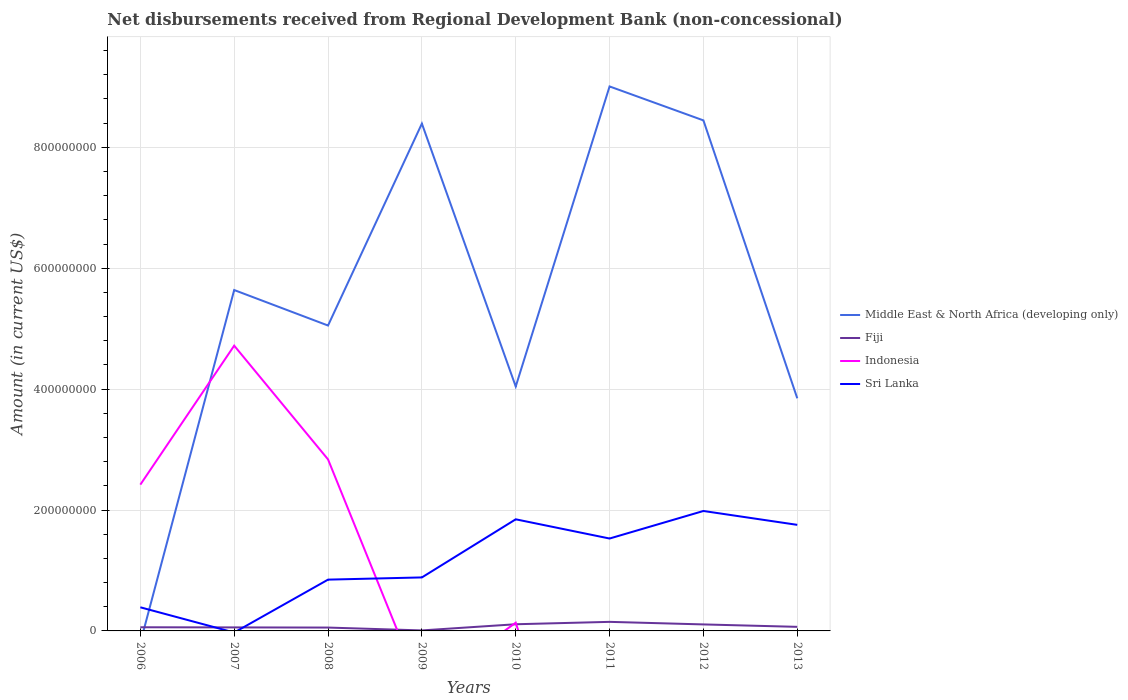Does the line corresponding to Fiji intersect with the line corresponding to Indonesia?
Your response must be concise. Yes. Across all years, what is the maximum amount of disbursements received from Regional Development Bank in Fiji?
Your response must be concise. 8.38e+05. What is the total amount of disbursements received from Regional Development Bank in Middle East & North Africa (developing only) in the graph?
Give a very brief answer. -2.75e+08. What is the difference between the highest and the second highest amount of disbursements received from Regional Development Bank in Middle East & North Africa (developing only)?
Keep it short and to the point. 9.01e+08. How many lines are there?
Your response must be concise. 4. How many years are there in the graph?
Make the answer very short. 8. What is the difference between two consecutive major ticks on the Y-axis?
Provide a succinct answer. 2.00e+08. Does the graph contain grids?
Your answer should be very brief. Yes. What is the title of the graph?
Offer a very short reply. Net disbursements received from Regional Development Bank (non-concessional). Does "Egypt, Arab Rep." appear as one of the legend labels in the graph?
Your answer should be very brief. No. What is the label or title of the Y-axis?
Keep it short and to the point. Amount (in current US$). What is the Amount (in current US$) in Fiji in 2006?
Provide a short and direct response. 6.05e+06. What is the Amount (in current US$) of Indonesia in 2006?
Give a very brief answer. 2.42e+08. What is the Amount (in current US$) of Sri Lanka in 2006?
Provide a succinct answer. 3.91e+07. What is the Amount (in current US$) of Middle East & North Africa (developing only) in 2007?
Your answer should be compact. 5.64e+08. What is the Amount (in current US$) in Fiji in 2007?
Keep it short and to the point. 5.80e+06. What is the Amount (in current US$) of Indonesia in 2007?
Ensure brevity in your answer.  4.72e+08. What is the Amount (in current US$) in Middle East & North Africa (developing only) in 2008?
Your response must be concise. 5.05e+08. What is the Amount (in current US$) of Fiji in 2008?
Give a very brief answer. 5.56e+06. What is the Amount (in current US$) of Indonesia in 2008?
Offer a terse response. 2.84e+08. What is the Amount (in current US$) of Sri Lanka in 2008?
Offer a very short reply. 8.48e+07. What is the Amount (in current US$) in Middle East & North Africa (developing only) in 2009?
Your answer should be very brief. 8.39e+08. What is the Amount (in current US$) in Fiji in 2009?
Ensure brevity in your answer.  8.38e+05. What is the Amount (in current US$) of Sri Lanka in 2009?
Offer a terse response. 8.85e+07. What is the Amount (in current US$) in Middle East & North Africa (developing only) in 2010?
Your answer should be compact. 4.04e+08. What is the Amount (in current US$) in Fiji in 2010?
Keep it short and to the point. 1.10e+07. What is the Amount (in current US$) of Indonesia in 2010?
Offer a terse response. 1.36e+07. What is the Amount (in current US$) of Sri Lanka in 2010?
Offer a very short reply. 1.85e+08. What is the Amount (in current US$) in Middle East & North Africa (developing only) in 2011?
Your response must be concise. 9.01e+08. What is the Amount (in current US$) in Fiji in 2011?
Make the answer very short. 1.50e+07. What is the Amount (in current US$) of Indonesia in 2011?
Offer a very short reply. 0. What is the Amount (in current US$) in Sri Lanka in 2011?
Your answer should be compact. 1.53e+08. What is the Amount (in current US$) in Middle East & North Africa (developing only) in 2012?
Your response must be concise. 8.45e+08. What is the Amount (in current US$) in Fiji in 2012?
Give a very brief answer. 1.07e+07. What is the Amount (in current US$) in Indonesia in 2012?
Offer a very short reply. 0. What is the Amount (in current US$) in Sri Lanka in 2012?
Provide a short and direct response. 1.98e+08. What is the Amount (in current US$) of Middle East & North Africa (developing only) in 2013?
Give a very brief answer. 3.85e+08. What is the Amount (in current US$) of Fiji in 2013?
Make the answer very short. 6.74e+06. What is the Amount (in current US$) of Indonesia in 2013?
Ensure brevity in your answer.  0. What is the Amount (in current US$) of Sri Lanka in 2013?
Give a very brief answer. 1.75e+08. Across all years, what is the maximum Amount (in current US$) in Middle East & North Africa (developing only)?
Your answer should be compact. 9.01e+08. Across all years, what is the maximum Amount (in current US$) of Fiji?
Provide a succinct answer. 1.50e+07. Across all years, what is the maximum Amount (in current US$) in Indonesia?
Offer a very short reply. 4.72e+08. Across all years, what is the maximum Amount (in current US$) of Sri Lanka?
Your answer should be very brief. 1.98e+08. Across all years, what is the minimum Amount (in current US$) in Middle East & North Africa (developing only)?
Offer a very short reply. 0. Across all years, what is the minimum Amount (in current US$) of Fiji?
Offer a very short reply. 8.38e+05. Across all years, what is the minimum Amount (in current US$) in Indonesia?
Your answer should be compact. 0. What is the total Amount (in current US$) of Middle East & North Africa (developing only) in the graph?
Your answer should be compact. 4.44e+09. What is the total Amount (in current US$) of Fiji in the graph?
Your answer should be compact. 6.18e+07. What is the total Amount (in current US$) of Indonesia in the graph?
Your answer should be compact. 1.01e+09. What is the total Amount (in current US$) of Sri Lanka in the graph?
Ensure brevity in your answer.  9.24e+08. What is the difference between the Amount (in current US$) in Fiji in 2006 and that in 2007?
Your response must be concise. 2.49e+05. What is the difference between the Amount (in current US$) of Indonesia in 2006 and that in 2007?
Give a very brief answer. -2.30e+08. What is the difference between the Amount (in current US$) in Fiji in 2006 and that in 2008?
Provide a short and direct response. 4.96e+05. What is the difference between the Amount (in current US$) in Indonesia in 2006 and that in 2008?
Offer a terse response. -4.17e+07. What is the difference between the Amount (in current US$) in Sri Lanka in 2006 and that in 2008?
Offer a very short reply. -4.58e+07. What is the difference between the Amount (in current US$) of Fiji in 2006 and that in 2009?
Give a very brief answer. 5.22e+06. What is the difference between the Amount (in current US$) of Sri Lanka in 2006 and that in 2009?
Your answer should be very brief. -4.94e+07. What is the difference between the Amount (in current US$) of Fiji in 2006 and that in 2010?
Offer a terse response. -4.98e+06. What is the difference between the Amount (in current US$) in Indonesia in 2006 and that in 2010?
Give a very brief answer. 2.28e+08. What is the difference between the Amount (in current US$) in Sri Lanka in 2006 and that in 2010?
Give a very brief answer. -1.46e+08. What is the difference between the Amount (in current US$) of Fiji in 2006 and that in 2011?
Provide a short and direct response. -8.93e+06. What is the difference between the Amount (in current US$) in Sri Lanka in 2006 and that in 2011?
Give a very brief answer. -1.14e+08. What is the difference between the Amount (in current US$) of Fiji in 2006 and that in 2012?
Your response must be concise. -4.69e+06. What is the difference between the Amount (in current US$) of Sri Lanka in 2006 and that in 2012?
Your response must be concise. -1.59e+08. What is the difference between the Amount (in current US$) in Fiji in 2006 and that in 2013?
Provide a succinct answer. -6.84e+05. What is the difference between the Amount (in current US$) in Sri Lanka in 2006 and that in 2013?
Your answer should be very brief. -1.36e+08. What is the difference between the Amount (in current US$) of Middle East & North Africa (developing only) in 2007 and that in 2008?
Provide a succinct answer. 5.87e+07. What is the difference between the Amount (in current US$) of Fiji in 2007 and that in 2008?
Your response must be concise. 2.47e+05. What is the difference between the Amount (in current US$) of Indonesia in 2007 and that in 2008?
Offer a terse response. 1.88e+08. What is the difference between the Amount (in current US$) of Middle East & North Africa (developing only) in 2007 and that in 2009?
Your response must be concise. -2.75e+08. What is the difference between the Amount (in current US$) in Fiji in 2007 and that in 2009?
Offer a terse response. 4.97e+06. What is the difference between the Amount (in current US$) of Middle East & North Africa (developing only) in 2007 and that in 2010?
Your answer should be very brief. 1.60e+08. What is the difference between the Amount (in current US$) in Fiji in 2007 and that in 2010?
Your answer should be very brief. -5.23e+06. What is the difference between the Amount (in current US$) of Indonesia in 2007 and that in 2010?
Give a very brief answer. 4.58e+08. What is the difference between the Amount (in current US$) in Middle East & North Africa (developing only) in 2007 and that in 2011?
Offer a very short reply. -3.37e+08. What is the difference between the Amount (in current US$) of Fiji in 2007 and that in 2011?
Keep it short and to the point. -9.18e+06. What is the difference between the Amount (in current US$) of Middle East & North Africa (developing only) in 2007 and that in 2012?
Your answer should be very brief. -2.81e+08. What is the difference between the Amount (in current US$) in Fiji in 2007 and that in 2012?
Offer a terse response. -4.94e+06. What is the difference between the Amount (in current US$) in Middle East & North Africa (developing only) in 2007 and that in 2013?
Provide a short and direct response. 1.79e+08. What is the difference between the Amount (in current US$) of Fiji in 2007 and that in 2013?
Offer a terse response. -9.33e+05. What is the difference between the Amount (in current US$) in Middle East & North Africa (developing only) in 2008 and that in 2009?
Your response must be concise. -3.34e+08. What is the difference between the Amount (in current US$) of Fiji in 2008 and that in 2009?
Your answer should be compact. 4.72e+06. What is the difference between the Amount (in current US$) of Sri Lanka in 2008 and that in 2009?
Offer a terse response. -3.64e+06. What is the difference between the Amount (in current US$) of Middle East & North Africa (developing only) in 2008 and that in 2010?
Offer a terse response. 1.01e+08. What is the difference between the Amount (in current US$) of Fiji in 2008 and that in 2010?
Offer a very short reply. -5.48e+06. What is the difference between the Amount (in current US$) in Indonesia in 2008 and that in 2010?
Ensure brevity in your answer.  2.70e+08. What is the difference between the Amount (in current US$) in Sri Lanka in 2008 and that in 2010?
Make the answer very short. -9.98e+07. What is the difference between the Amount (in current US$) of Middle East & North Africa (developing only) in 2008 and that in 2011?
Make the answer very short. -3.96e+08. What is the difference between the Amount (in current US$) in Fiji in 2008 and that in 2011?
Keep it short and to the point. -9.43e+06. What is the difference between the Amount (in current US$) of Sri Lanka in 2008 and that in 2011?
Keep it short and to the point. -6.80e+07. What is the difference between the Amount (in current US$) in Middle East & North Africa (developing only) in 2008 and that in 2012?
Offer a very short reply. -3.39e+08. What is the difference between the Amount (in current US$) in Fiji in 2008 and that in 2012?
Offer a very short reply. -5.18e+06. What is the difference between the Amount (in current US$) in Sri Lanka in 2008 and that in 2012?
Provide a short and direct response. -1.14e+08. What is the difference between the Amount (in current US$) of Middle East & North Africa (developing only) in 2008 and that in 2013?
Keep it short and to the point. 1.20e+08. What is the difference between the Amount (in current US$) in Fiji in 2008 and that in 2013?
Offer a terse response. -1.18e+06. What is the difference between the Amount (in current US$) of Sri Lanka in 2008 and that in 2013?
Give a very brief answer. -9.06e+07. What is the difference between the Amount (in current US$) of Middle East & North Africa (developing only) in 2009 and that in 2010?
Ensure brevity in your answer.  4.35e+08. What is the difference between the Amount (in current US$) of Fiji in 2009 and that in 2010?
Your response must be concise. -1.02e+07. What is the difference between the Amount (in current US$) in Sri Lanka in 2009 and that in 2010?
Provide a short and direct response. -9.62e+07. What is the difference between the Amount (in current US$) in Middle East & North Africa (developing only) in 2009 and that in 2011?
Offer a terse response. -6.15e+07. What is the difference between the Amount (in current US$) in Fiji in 2009 and that in 2011?
Provide a short and direct response. -1.42e+07. What is the difference between the Amount (in current US$) of Sri Lanka in 2009 and that in 2011?
Provide a short and direct response. -6.44e+07. What is the difference between the Amount (in current US$) of Middle East & North Africa (developing only) in 2009 and that in 2012?
Offer a very short reply. -5.28e+06. What is the difference between the Amount (in current US$) in Fiji in 2009 and that in 2012?
Your answer should be very brief. -9.90e+06. What is the difference between the Amount (in current US$) of Sri Lanka in 2009 and that in 2012?
Provide a succinct answer. -1.10e+08. What is the difference between the Amount (in current US$) of Middle East & North Africa (developing only) in 2009 and that in 2013?
Offer a terse response. 4.54e+08. What is the difference between the Amount (in current US$) of Fiji in 2009 and that in 2013?
Offer a terse response. -5.90e+06. What is the difference between the Amount (in current US$) in Sri Lanka in 2009 and that in 2013?
Your response must be concise. -8.70e+07. What is the difference between the Amount (in current US$) of Middle East & North Africa (developing only) in 2010 and that in 2011?
Make the answer very short. -4.96e+08. What is the difference between the Amount (in current US$) of Fiji in 2010 and that in 2011?
Offer a terse response. -3.95e+06. What is the difference between the Amount (in current US$) of Sri Lanka in 2010 and that in 2011?
Ensure brevity in your answer.  3.18e+07. What is the difference between the Amount (in current US$) in Middle East & North Africa (developing only) in 2010 and that in 2012?
Offer a very short reply. -4.40e+08. What is the difference between the Amount (in current US$) in Fiji in 2010 and that in 2012?
Provide a short and direct response. 2.99e+05. What is the difference between the Amount (in current US$) of Sri Lanka in 2010 and that in 2012?
Keep it short and to the point. -1.38e+07. What is the difference between the Amount (in current US$) of Middle East & North Africa (developing only) in 2010 and that in 2013?
Give a very brief answer. 1.95e+07. What is the difference between the Amount (in current US$) of Fiji in 2010 and that in 2013?
Keep it short and to the point. 4.30e+06. What is the difference between the Amount (in current US$) in Sri Lanka in 2010 and that in 2013?
Keep it short and to the point. 9.17e+06. What is the difference between the Amount (in current US$) of Middle East & North Africa (developing only) in 2011 and that in 2012?
Make the answer very short. 5.62e+07. What is the difference between the Amount (in current US$) in Fiji in 2011 and that in 2012?
Offer a very short reply. 4.25e+06. What is the difference between the Amount (in current US$) of Sri Lanka in 2011 and that in 2012?
Make the answer very short. -4.56e+07. What is the difference between the Amount (in current US$) in Middle East & North Africa (developing only) in 2011 and that in 2013?
Provide a succinct answer. 5.16e+08. What is the difference between the Amount (in current US$) of Fiji in 2011 and that in 2013?
Make the answer very short. 8.25e+06. What is the difference between the Amount (in current US$) in Sri Lanka in 2011 and that in 2013?
Provide a succinct answer. -2.26e+07. What is the difference between the Amount (in current US$) of Middle East & North Africa (developing only) in 2012 and that in 2013?
Provide a short and direct response. 4.60e+08. What is the difference between the Amount (in current US$) in Fiji in 2012 and that in 2013?
Keep it short and to the point. 4.00e+06. What is the difference between the Amount (in current US$) in Sri Lanka in 2012 and that in 2013?
Ensure brevity in your answer.  2.29e+07. What is the difference between the Amount (in current US$) in Fiji in 2006 and the Amount (in current US$) in Indonesia in 2007?
Your answer should be compact. -4.66e+08. What is the difference between the Amount (in current US$) of Fiji in 2006 and the Amount (in current US$) of Indonesia in 2008?
Give a very brief answer. -2.78e+08. What is the difference between the Amount (in current US$) of Fiji in 2006 and the Amount (in current US$) of Sri Lanka in 2008?
Give a very brief answer. -7.88e+07. What is the difference between the Amount (in current US$) of Indonesia in 2006 and the Amount (in current US$) of Sri Lanka in 2008?
Offer a terse response. 1.57e+08. What is the difference between the Amount (in current US$) of Fiji in 2006 and the Amount (in current US$) of Sri Lanka in 2009?
Provide a succinct answer. -8.24e+07. What is the difference between the Amount (in current US$) of Indonesia in 2006 and the Amount (in current US$) of Sri Lanka in 2009?
Keep it short and to the point. 1.53e+08. What is the difference between the Amount (in current US$) in Fiji in 2006 and the Amount (in current US$) in Indonesia in 2010?
Keep it short and to the point. -7.55e+06. What is the difference between the Amount (in current US$) of Fiji in 2006 and the Amount (in current US$) of Sri Lanka in 2010?
Ensure brevity in your answer.  -1.79e+08. What is the difference between the Amount (in current US$) of Indonesia in 2006 and the Amount (in current US$) of Sri Lanka in 2010?
Keep it short and to the point. 5.73e+07. What is the difference between the Amount (in current US$) of Fiji in 2006 and the Amount (in current US$) of Sri Lanka in 2011?
Give a very brief answer. -1.47e+08. What is the difference between the Amount (in current US$) of Indonesia in 2006 and the Amount (in current US$) of Sri Lanka in 2011?
Ensure brevity in your answer.  8.91e+07. What is the difference between the Amount (in current US$) of Fiji in 2006 and the Amount (in current US$) of Sri Lanka in 2012?
Give a very brief answer. -1.92e+08. What is the difference between the Amount (in current US$) in Indonesia in 2006 and the Amount (in current US$) in Sri Lanka in 2012?
Keep it short and to the point. 4.36e+07. What is the difference between the Amount (in current US$) of Fiji in 2006 and the Amount (in current US$) of Sri Lanka in 2013?
Keep it short and to the point. -1.69e+08. What is the difference between the Amount (in current US$) of Indonesia in 2006 and the Amount (in current US$) of Sri Lanka in 2013?
Provide a succinct answer. 6.65e+07. What is the difference between the Amount (in current US$) in Middle East & North Africa (developing only) in 2007 and the Amount (in current US$) in Fiji in 2008?
Make the answer very short. 5.58e+08. What is the difference between the Amount (in current US$) of Middle East & North Africa (developing only) in 2007 and the Amount (in current US$) of Indonesia in 2008?
Ensure brevity in your answer.  2.80e+08. What is the difference between the Amount (in current US$) in Middle East & North Africa (developing only) in 2007 and the Amount (in current US$) in Sri Lanka in 2008?
Ensure brevity in your answer.  4.79e+08. What is the difference between the Amount (in current US$) in Fiji in 2007 and the Amount (in current US$) in Indonesia in 2008?
Ensure brevity in your answer.  -2.78e+08. What is the difference between the Amount (in current US$) of Fiji in 2007 and the Amount (in current US$) of Sri Lanka in 2008?
Give a very brief answer. -7.90e+07. What is the difference between the Amount (in current US$) in Indonesia in 2007 and the Amount (in current US$) in Sri Lanka in 2008?
Ensure brevity in your answer.  3.87e+08. What is the difference between the Amount (in current US$) in Middle East & North Africa (developing only) in 2007 and the Amount (in current US$) in Fiji in 2009?
Offer a terse response. 5.63e+08. What is the difference between the Amount (in current US$) of Middle East & North Africa (developing only) in 2007 and the Amount (in current US$) of Sri Lanka in 2009?
Keep it short and to the point. 4.75e+08. What is the difference between the Amount (in current US$) in Fiji in 2007 and the Amount (in current US$) in Sri Lanka in 2009?
Your answer should be compact. -8.27e+07. What is the difference between the Amount (in current US$) in Indonesia in 2007 and the Amount (in current US$) in Sri Lanka in 2009?
Make the answer very short. 3.83e+08. What is the difference between the Amount (in current US$) in Middle East & North Africa (developing only) in 2007 and the Amount (in current US$) in Fiji in 2010?
Provide a short and direct response. 5.53e+08. What is the difference between the Amount (in current US$) in Middle East & North Africa (developing only) in 2007 and the Amount (in current US$) in Indonesia in 2010?
Offer a very short reply. 5.50e+08. What is the difference between the Amount (in current US$) in Middle East & North Africa (developing only) in 2007 and the Amount (in current US$) in Sri Lanka in 2010?
Make the answer very short. 3.79e+08. What is the difference between the Amount (in current US$) of Fiji in 2007 and the Amount (in current US$) of Indonesia in 2010?
Ensure brevity in your answer.  -7.80e+06. What is the difference between the Amount (in current US$) of Fiji in 2007 and the Amount (in current US$) of Sri Lanka in 2010?
Offer a terse response. -1.79e+08. What is the difference between the Amount (in current US$) in Indonesia in 2007 and the Amount (in current US$) in Sri Lanka in 2010?
Make the answer very short. 2.87e+08. What is the difference between the Amount (in current US$) of Middle East & North Africa (developing only) in 2007 and the Amount (in current US$) of Fiji in 2011?
Give a very brief answer. 5.49e+08. What is the difference between the Amount (in current US$) of Middle East & North Africa (developing only) in 2007 and the Amount (in current US$) of Sri Lanka in 2011?
Your answer should be very brief. 4.11e+08. What is the difference between the Amount (in current US$) of Fiji in 2007 and the Amount (in current US$) of Sri Lanka in 2011?
Offer a terse response. -1.47e+08. What is the difference between the Amount (in current US$) of Indonesia in 2007 and the Amount (in current US$) of Sri Lanka in 2011?
Give a very brief answer. 3.19e+08. What is the difference between the Amount (in current US$) of Middle East & North Africa (developing only) in 2007 and the Amount (in current US$) of Fiji in 2012?
Give a very brief answer. 5.53e+08. What is the difference between the Amount (in current US$) of Middle East & North Africa (developing only) in 2007 and the Amount (in current US$) of Sri Lanka in 2012?
Provide a short and direct response. 3.65e+08. What is the difference between the Amount (in current US$) in Fiji in 2007 and the Amount (in current US$) in Sri Lanka in 2012?
Give a very brief answer. -1.93e+08. What is the difference between the Amount (in current US$) in Indonesia in 2007 and the Amount (in current US$) in Sri Lanka in 2012?
Provide a succinct answer. 2.73e+08. What is the difference between the Amount (in current US$) of Middle East & North Africa (developing only) in 2007 and the Amount (in current US$) of Fiji in 2013?
Your response must be concise. 5.57e+08. What is the difference between the Amount (in current US$) of Middle East & North Africa (developing only) in 2007 and the Amount (in current US$) of Sri Lanka in 2013?
Provide a succinct answer. 3.88e+08. What is the difference between the Amount (in current US$) in Fiji in 2007 and the Amount (in current US$) in Sri Lanka in 2013?
Ensure brevity in your answer.  -1.70e+08. What is the difference between the Amount (in current US$) of Indonesia in 2007 and the Amount (in current US$) of Sri Lanka in 2013?
Your answer should be compact. 2.96e+08. What is the difference between the Amount (in current US$) in Middle East & North Africa (developing only) in 2008 and the Amount (in current US$) in Fiji in 2009?
Make the answer very short. 5.04e+08. What is the difference between the Amount (in current US$) in Middle East & North Africa (developing only) in 2008 and the Amount (in current US$) in Sri Lanka in 2009?
Ensure brevity in your answer.  4.17e+08. What is the difference between the Amount (in current US$) in Fiji in 2008 and the Amount (in current US$) in Sri Lanka in 2009?
Make the answer very short. -8.29e+07. What is the difference between the Amount (in current US$) of Indonesia in 2008 and the Amount (in current US$) of Sri Lanka in 2009?
Give a very brief answer. 1.95e+08. What is the difference between the Amount (in current US$) of Middle East & North Africa (developing only) in 2008 and the Amount (in current US$) of Fiji in 2010?
Your answer should be compact. 4.94e+08. What is the difference between the Amount (in current US$) in Middle East & North Africa (developing only) in 2008 and the Amount (in current US$) in Indonesia in 2010?
Your answer should be very brief. 4.92e+08. What is the difference between the Amount (in current US$) in Middle East & North Africa (developing only) in 2008 and the Amount (in current US$) in Sri Lanka in 2010?
Offer a terse response. 3.21e+08. What is the difference between the Amount (in current US$) of Fiji in 2008 and the Amount (in current US$) of Indonesia in 2010?
Give a very brief answer. -8.04e+06. What is the difference between the Amount (in current US$) in Fiji in 2008 and the Amount (in current US$) in Sri Lanka in 2010?
Your answer should be compact. -1.79e+08. What is the difference between the Amount (in current US$) in Indonesia in 2008 and the Amount (in current US$) in Sri Lanka in 2010?
Offer a terse response. 9.91e+07. What is the difference between the Amount (in current US$) in Middle East & North Africa (developing only) in 2008 and the Amount (in current US$) in Fiji in 2011?
Provide a succinct answer. 4.90e+08. What is the difference between the Amount (in current US$) of Middle East & North Africa (developing only) in 2008 and the Amount (in current US$) of Sri Lanka in 2011?
Make the answer very short. 3.52e+08. What is the difference between the Amount (in current US$) of Fiji in 2008 and the Amount (in current US$) of Sri Lanka in 2011?
Your response must be concise. -1.47e+08. What is the difference between the Amount (in current US$) of Indonesia in 2008 and the Amount (in current US$) of Sri Lanka in 2011?
Provide a short and direct response. 1.31e+08. What is the difference between the Amount (in current US$) in Middle East & North Africa (developing only) in 2008 and the Amount (in current US$) in Fiji in 2012?
Make the answer very short. 4.94e+08. What is the difference between the Amount (in current US$) of Middle East & North Africa (developing only) in 2008 and the Amount (in current US$) of Sri Lanka in 2012?
Offer a terse response. 3.07e+08. What is the difference between the Amount (in current US$) of Fiji in 2008 and the Amount (in current US$) of Sri Lanka in 2012?
Make the answer very short. -1.93e+08. What is the difference between the Amount (in current US$) in Indonesia in 2008 and the Amount (in current US$) in Sri Lanka in 2012?
Your answer should be very brief. 8.53e+07. What is the difference between the Amount (in current US$) of Middle East & North Africa (developing only) in 2008 and the Amount (in current US$) of Fiji in 2013?
Offer a very short reply. 4.98e+08. What is the difference between the Amount (in current US$) in Middle East & North Africa (developing only) in 2008 and the Amount (in current US$) in Sri Lanka in 2013?
Keep it short and to the point. 3.30e+08. What is the difference between the Amount (in current US$) of Fiji in 2008 and the Amount (in current US$) of Sri Lanka in 2013?
Provide a succinct answer. -1.70e+08. What is the difference between the Amount (in current US$) in Indonesia in 2008 and the Amount (in current US$) in Sri Lanka in 2013?
Your answer should be compact. 1.08e+08. What is the difference between the Amount (in current US$) in Middle East & North Africa (developing only) in 2009 and the Amount (in current US$) in Fiji in 2010?
Your answer should be compact. 8.28e+08. What is the difference between the Amount (in current US$) in Middle East & North Africa (developing only) in 2009 and the Amount (in current US$) in Indonesia in 2010?
Keep it short and to the point. 8.26e+08. What is the difference between the Amount (in current US$) of Middle East & North Africa (developing only) in 2009 and the Amount (in current US$) of Sri Lanka in 2010?
Offer a terse response. 6.55e+08. What is the difference between the Amount (in current US$) of Fiji in 2009 and the Amount (in current US$) of Indonesia in 2010?
Ensure brevity in your answer.  -1.28e+07. What is the difference between the Amount (in current US$) in Fiji in 2009 and the Amount (in current US$) in Sri Lanka in 2010?
Ensure brevity in your answer.  -1.84e+08. What is the difference between the Amount (in current US$) in Middle East & North Africa (developing only) in 2009 and the Amount (in current US$) in Fiji in 2011?
Your answer should be very brief. 8.24e+08. What is the difference between the Amount (in current US$) in Middle East & North Africa (developing only) in 2009 and the Amount (in current US$) in Sri Lanka in 2011?
Ensure brevity in your answer.  6.86e+08. What is the difference between the Amount (in current US$) of Fiji in 2009 and the Amount (in current US$) of Sri Lanka in 2011?
Offer a terse response. -1.52e+08. What is the difference between the Amount (in current US$) of Middle East & North Africa (developing only) in 2009 and the Amount (in current US$) of Fiji in 2012?
Your response must be concise. 8.28e+08. What is the difference between the Amount (in current US$) of Middle East & North Africa (developing only) in 2009 and the Amount (in current US$) of Sri Lanka in 2012?
Your response must be concise. 6.41e+08. What is the difference between the Amount (in current US$) in Fiji in 2009 and the Amount (in current US$) in Sri Lanka in 2012?
Your response must be concise. -1.98e+08. What is the difference between the Amount (in current US$) in Middle East & North Africa (developing only) in 2009 and the Amount (in current US$) in Fiji in 2013?
Your answer should be compact. 8.32e+08. What is the difference between the Amount (in current US$) in Middle East & North Africa (developing only) in 2009 and the Amount (in current US$) in Sri Lanka in 2013?
Your answer should be compact. 6.64e+08. What is the difference between the Amount (in current US$) of Fiji in 2009 and the Amount (in current US$) of Sri Lanka in 2013?
Give a very brief answer. -1.75e+08. What is the difference between the Amount (in current US$) in Middle East & North Africa (developing only) in 2010 and the Amount (in current US$) in Fiji in 2011?
Your answer should be very brief. 3.89e+08. What is the difference between the Amount (in current US$) in Middle East & North Africa (developing only) in 2010 and the Amount (in current US$) in Sri Lanka in 2011?
Your answer should be compact. 2.51e+08. What is the difference between the Amount (in current US$) in Fiji in 2010 and the Amount (in current US$) in Sri Lanka in 2011?
Make the answer very short. -1.42e+08. What is the difference between the Amount (in current US$) of Indonesia in 2010 and the Amount (in current US$) of Sri Lanka in 2011?
Make the answer very short. -1.39e+08. What is the difference between the Amount (in current US$) of Middle East & North Africa (developing only) in 2010 and the Amount (in current US$) of Fiji in 2012?
Your answer should be compact. 3.94e+08. What is the difference between the Amount (in current US$) of Middle East & North Africa (developing only) in 2010 and the Amount (in current US$) of Sri Lanka in 2012?
Provide a succinct answer. 2.06e+08. What is the difference between the Amount (in current US$) of Fiji in 2010 and the Amount (in current US$) of Sri Lanka in 2012?
Provide a short and direct response. -1.87e+08. What is the difference between the Amount (in current US$) of Indonesia in 2010 and the Amount (in current US$) of Sri Lanka in 2012?
Your response must be concise. -1.85e+08. What is the difference between the Amount (in current US$) in Middle East & North Africa (developing only) in 2010 and the Amount (in current US$) in Fiji in 2013?
Keep it short and to the point. 3.98e+08. What is the difference between the Amount (in current US$) in Middle East & North Africa (developing only) in 2010 and the Amount (in current US$) in Sri Lanka in 2013?
Offer a very short reply. 2.29e+08. What is the difference between the Amount (in current US$) of Fiji in 2010 and the Amount (in current US$) of Sri Lanka in 2013?
Ensure brevity in your answer.  -1.64e+08. What is the difference between the Amount (in current US$) of Indonesia in 2010 and the Amount (in current US$) of Sri Lanka in 2013?
Your answer should be very brief. -1.62e+08. What is the difference between the Amount (in current US$) of Middle East & North Africa (developing only) in 2011 and the Amount (in current US$) of Fiji in 2012?
Your answer should be very brief. 8.90e+08. What is the difference between the Amount (in current US$) in Middle East & North Africa (developing only) in 2011 and the Amount (in current US$) in Sri Lanka in 2012?
Offer a very short reply. 7.02e+08. What is the difference between the Amount (in current US$) of Fiji in 2011 and the Amount (in current US$) of Sri Lanka in 2012?
Make the answer very short. -1.83e+08. What is the difference between the Amount (in current US$) in Middle East & North Africa (developing only) in 2011 and the Amount (in current US$) in Fiji in 2013?
Provide a short and direct response. 8.94e+08. What is the difference between the Amount (in current US$) in Middle East & North Africa (developing only) in 2011 and the Amount (in current US$) in Sri Lanka in 2013?
Ensure brevity in your answer.  7.25e+08. What is the difference between the Amount (in current US$) of Fiji in 2011 and the Amount (in current US$) of Sri Lanka in 2013?
Your answer should be very brief. -1.60e+08. What is the difference between the Amount (in current US$) of Middle East & North Africa (developing only) in 2012 and the Amount (in current US$) of Fiji in 2013?
Offer a terse response. 8.38e+08. What is the difference between the Amount (in current US$) in Middle East & North Africa (developing only) in 2012 and the Amount (in current US$) in Sri Lanka in 2013?
Give a very brief answer. 6.69e+08. What is the difference between the Amount (in current US$) in Fiji in 2012 and the Amount (in current US$) in Sri Lanka in 2013?
Keep it short and to the point. -1.65e+08. What is the average Amount (in current US$) in Middle East & North Africa (developing only) per year?
Provide a short and direct response. 5.55e+08. What is the average Amount (in current US$) of Fiji per year?
Ensure brevity in your answer.  7.72e+06. What is the average Amount (in current US$) of Indonesia per year?
Make the answer very short. 1.26e+08. What is the average Amount (in current US$) of Sri Lanka per year?
Your response must be concise. 1.15e+08. In the year 2006, what is the difference between the Amount (in current US$) of Fiji and Amount (in current US$) of Indonesia?
Make the answer very short. -2.36e+08. In the year 2006, what is the difference between the Amount (in current US$) in Fiji and Amount (in current US$) in Sri Lanka?
Offer a very short reply. -3.30e+07. In the year 2006, what is the difference between the Amount (in current US$) of Indonesia and Amount (in current US$) of Sri Lanka?
Ensure brevity in your answer.  2.03e+08. In the year 2007, what is the difference between the Amount (in current US$) of Middle East & North Africa (developing only) and Amount (in current US$) of Fiji?
Keep it short and to the point. 5.58e+08. In the year 2007, what is the difference between the Amount (in current US$) in Middle East & North Africa (developing only) and Amount (in current US$) in Indonesia?
Keep it short and to the point. 9.20e+07. In the year 2007, what is the difference between the Amount (in current US$) in Fiji and Amount (in current US$) in Indonesia?
Keep it short and to the point. -4.66e+08. In the year 2008, what is the difference between the Amount (in current US$) of Middle East & North Africa (developing only) and Amount (in current US$) of Fiji?
Ensure brevity in your answer.  5.00e+08. In the year 2008, what is the difference between the Amount (in current US$) in Middle East & North Africa (developing only) and Amount (in current US$) in Indonesia?
Ensure brevity in your answer.  2.21e+08. In the year 2008, what is the difference between the Amount (in current US$) in Middle East & North Africa (developing only) and Amount (in current US$) in Sri Lanka?
Give a very brief answer. 4.20e+08. In the year 2008, what is the difference between the Amount (in current US$) of Fiji and Amount (in current US$) of Indonesia?
Your answer should be very brief. -2.78e+08. In the year 2008, what is the difference between the Amount (in current US$) of Fiji and Amount (in current US$) of Sri Lanka?
Make the answer very short. -7.93e+07. In the year 2008, what is the difference between the Amount (in current US$) of Indonesia and Amount (in current US$) of Sri Lanka?
Give a very brief answer. 1.99e+08. In the year 2009, what is the difference between the Amount (in current US$) in Middle East & North Africa (developing only) and Amount (in current US$) in Fiji?
Your response must be concise. 8.38e+08. In the year 2009, what is the difference between the Amount (in current US$) in Middle East & North Africa (developing only) and Amount (in current US$) in Sri Lanka?
Your answer should be very brief. 7.51e+08. In the year 2009, what is the difference between the Amount (in current US$) of Fiji and Amount (in current US$) of Sri Lanka?
Keep it short and to the point. -8.77e+07. In the year 2010, what is the difference between the Amount (in current US$) in Middle East & North Africa (developing only) and Amount (in current US$) in Fiji?
Make the answer very short. 3.93e+08. In the year 2010, what is the difference between the Amount (in current US$) of Middle East & North Africa (developing only) and Amount (in current US$) of Indonesia?
Provide a succinct answer. 3.91e+08. In the year 2010, what is the difference between the Amount (in current US$) of Middle East & North Africa (developing only) and Amount (in current US$) of Sri Lanka?
Offer a terse response. 2.20e+08. In the year 2010, what is the difference between the Amount (in current US$) of Fiji and Amount (in current US$) of Indonesia?
Your answer should be compact. -2.56e+06. In the year 2010, what is the difference between the Amount (in current US$) of Fiji and Amount (in current US$) of Sri Lanka?
Make the answer very short. -1.74e+08. In the year 2010, what is the difference between the Amount (in current US$) of Indonesia and Amount (in current US$) of Sri Lanka?
Keep it short and to the point. -1.71e+08. In the year 2011, what is the difference between the Amount (in current US$) of Middle East & North Africa (developing only) and Amount (in current US$) of Fiji?
Your answer should be compact. 8.86e+08. In the year 2011, what is the difference between the Amount (in current US$) in Middle East & North Africa (developing only) and Amount (in current US$) in Sri Lanka?
Make the answer very short. 7.48e+08. In the year 2011, what is the difference between the Amount (in current US$) in Fiji and Amount (in current US$) in Sri Lanka?
Provide a succinct answer. -1.38e+08. In the year 2012, what is the difference between the Amount (in current US$) of Middle East & North Africa (developing only) and Amount (in current US$) of Fiji?
Ensure brevity in your answer.  8.34e+08. In the year 2012, what is the difference between the Amount (in current US$) in Middle East & North Africa (developing only) and Amount (in current US$) in Sri Lanka?
Offer a very short reply. 6.46e+08. In the year 2012, what is the difference between the Amount (in current US$) in Fiji and Amount (in current US$) in Sri Lanka?
Provide a short and direct response. -1.88e+08. In the year 2013, what is the difference between the Amount (in current US$) in Middle East & North Africa (developing only) and Amount (in current US$) in Fiji?
Ensure brevity in your answer.  3.78e+08. In the year 2013, what is the difference between the Amount (in current US$) in Middle East & North Africa (developing only) and Amount (in current US$) in Sri Lanka?
Make the answer very short. 2.09e+08. In the year 2013, what is the difference between the Amount (in current US$) in Fiji and Amount (in current US$) in Sri Lanka?
Offer a terse response. -1.69e+08. What is the ratio of the Amount (in current US$) in Fiji in 2006 to that in 2007?
Your response must be concise. 1.04. What is the ratio of the Amount (in current US$) in Indonesia in 2006 to that in 2007?
Keep it short and to the point. 0.51. What is the ratio of the Amount (in current US$) in Fiji in 2006 to that in 2008?
Offer a very short reply. 1.09. What is the ratio of the Amount (in current US$) of Indonesia in 2006 to that in 2008?
Provide a short and direct response. 0.85. What is the ratio of the Amount (in current US$) of Sri Lanka in 2006 to that in 2008?
Make the answer very short. 0.46. What is the ratio of the Amount (in current US$) of Fiji in 2006 to that in 2009?
Offer a terse response. 7.22. What is the ratio of the Amount (in current US$) of Sri Lanka in 2006 to that in 2009?
Provide a succinct answer. 0.44. What is the ratio of the Amount (in current US$) in Fiji in 2006 to that in 2010?
Your answer should be very brief. 0.55. What is the ratio of the Amount (in current US$) in Indonesia in 2006 to that in 2010?
Make the answer very short. 17.79. What is the ratio of the Amount (in current US$) of Sri Lanka in 2006 to that in 2010?
Keep it short and to the point. 0.21. What is the ratio of the Amount (in current US$) in Fiji in 2006 to that in 2011?
Offer a very short reply. 0.4. What is the ratio of the Amount (in current US$) in Sri Lanka in 2006 to that in 2011?
Your answer should be very brief. 0.26. What is the ratio of the Amount (in current US$) of Fiji in 2006 to that in 2012?
Give a very brief answer. 0.56. What is the ratio of the Amount (in current US$) of Sri Lanka in 2006 to that in 2012?
Your response must be concise. 0.2. What is the ratio of the Amount (in current US$) of Fiji in 2006 to that in 2013?
Offer a terse response. 0.9. What is the ratio of the Amount (in current US$) of Sri Lanka in 2006 to that in 2013?
Your answer should be very brief. 0.22. What is the ratio of the Amount (in current US$) of Middle East & North Africa (developing only) in 2007 to that in 2008?
Ensure brevity in your answer.  1.12. What is the ratio of the Amount (in current US$) of Fiji in 2007 to that in 2008?
Make the answer very short. 1.04. What is the ratio of the Amount (in current US$) in Indonesia in 2007 to that in 2008?
Offer a terse response. 1.66. What is the ratio of the Amount (in current US$) of Middle East & North Africa (developing only) in 2007 to that in 2009?
Provide a succinct answer. 0.67. What is the ratio of the Amount (in current US$) in Fiji in 2007 to that in 2009?
Your answer should be compact. 6.93. What is the ratio of the Amount (in current US$) of Middle East & North Africa (developing only) in 2007 to that in 2010?
Offer a very short reply. 1.39. What is the ratio of the Amount (in current US$) in Fiji in 2007 to that in 2010?
Offer a very short reply. 0.53. What is the ratio of the Amount (in current US$) in Indonesia in 2007 to that in 2010?
Your answer should be compact. 34.7. What is the ratio of the Amount (in current US$) in Middle East & North Africa (developing only) in 2007 to that in 2011?
Ensure brevity in your answer.  0.63. What is the ratio of the Amount (in current US$) in Fiji in 2007 to that in 2011?
Offer a terse response. 0.39. What is the ratio of the Amount (in current US$) of Middle East & North Africa (developing only) in 2007 to that in 2012?
Ensure brevity in your answer.  0.67. What is the ratio of the Amount (in current US$) in Fiji in 2007 to that in 2012?
Provide a short and direct response. 0.54. What is the ratio of the Amount (in current US$) in Middle East & North Africa (developing only) in 2007 to that in 2013?
Offer a terse response. 1.47. What is the ratio of the Amount (in current US$) of Fiji in 2007 to that in 2013?
Offer a very short reply. 0.86. What is the ratio of the Amount (in current US$) of Middle East & North Africa (developing only) in 2008 to that in 2009?
Give a very brief answer. 0.6. What is the ratio of the Amount (in current US$) in Fiji in 2008 to that in 2009?
Offer a very short reply. 6.63. What is the ratio of the Amount (in current US$) of Sri Lanka in 2008 to that in 2009?
Provide a succinct answer. 0.96. What is the ratio of the Amount (in current US$) of Middle East & North Africa (developing only) in 2008 to that in 2010?
Your answer should be compact. 1.25. What is the ratio of the Amount (in current US$) of Fiji in 2008 to that in 2010?
Ensure brevity in your answer.  0.5. What is the ratio of the Amount (in current US$) in Indonesia in 2008 to that in 2010?
Your answer should be very brief. 20.86. What is the ratio of the Amount (in current US$) in Sri Lanka in 2008 to that in 2010?
Keep it short and to the point. 0.46. What is the ratio of the Amount (in current US$) in Middle East & North Africa (developing only) in 2008 to that in 2011?
Your answer should be compact. 0.56. What is the ratio of the Amount (in current US$) of Fiji in 2008 to that in 2011?
Your answer should be compact. 0.37. What is the ratio of the Amount (in current US$) in Sri Lanka in 2008 to that in 2011?
Make the answer very short. 0.56. What is the ratio of the Amount (in current US$) of Middle East & North Africa (developing only) in 2008 to that in 2012?
Keep it short and to the point. 0.6. What is the ratio of the Amount (in current US$) of Fiji in 2008 to that in 2012?
Keep it short and to the point. 0.52. What is the ratio of the Amount (in current US$) of Sri Lanka in 2008 to that in 2012?
Offer a terse response. 0.43. What is the ratio of the Amount (in current US$) in Middle East & North Africa (developing only) in 2008 to that in 2013?
Ensure brevity in your answer.  1.31. What is the ratio of the Amount (in current US$) in Fiji in 2008 to that in 2013?
Your answer should be compact. 0.82. What is the ratio of the Amount (in current US$) in Sri Lanka in 2008 to that in 2013?
Provide a succinct answer. 0.48. What is the ratio of the Amount (in current US$) of Middle East & North Africa (developing only) in 2009 to that in 2010?
Provide a succinct answer. 2.08. What is the ratio of the Amount (in current US$) in Fiji in 2009 to that in 2010?
Give a very brief answer. 0.08. What is the ratio of the Amount (in current US$) in Sri Lanka in 2009 to that in 2010?
Your response must be concise. 0.48. What is the ratio of the Amount (in current US$) of Middle East & North Africa (developing only) in 2009 to that in 2011?
Offer a terse response. 0.93. What is the ratio of the Amount (in current US$) of Fiji in 2009 to that in 2011?
Provide a short and direct response. 0.06. What is the ratio of the Amount (in current US$) of Sri Lanka in 2009 to that in 2011?
Ensure brevity in your answer.  0.58. What is the ratio of the Amount (in current US$) in Fiji in 2009 to that in 2012?
Provide a short and direct response. 0.08. What is the ratio of the Amount (in current US$) in Sri Lanka in 2009 to that in 2012?
Your answer should be very brief. 0.45. What is the ratio of the Amount (in current US$) in Middle East & North Africa (developing only) in 2009 to that in 2013?
Offer a terse response. 2.18. What is the ratio of the Amount (in current US$) of Fiji in 2009 to that in 2013?
Provide a succinct answer. 0.12. What is the ratio of the Amount (in current US$) of Sri Lanka in 2009 to that in 2013?
Make the answer very short. 0.5. What is the ratio of the Amount (in current US$) of Middle East & North Africa (developing only) in 2010 to that in 2011?
Give a very brief answer. 0.45. What is the ratio of the Amount (in current US$) in Fiji in 2010 to that in 2011?
Keep it short and to the point. 0.74. What is the ratio of the Amount (in current US$) in Sri Lanka in 2010 to that in 2011?
Provide a succinct answer. 1.21. What is the ratio of the Amount (in current US$) in Middle East & North Africa (developing only) in 2010 to that in 2012?
Offer a very short reply. 0.48. What is the ratio of the Amount (in current US$) of Fiji in 2010 to that in 2012?
Your answer should be compact. 1.03. What is the ratio of the Amount (in current US$) in Sri Lanka in 2010 to that in 2012?
Ensure brevity in your answer.  0.93. What is the ratio of the Amount (in current US$) in Middle East & North Africa (developing only) in 2010 to that in 2013?
Give a very brief answer. 1.05. What is the ratio of the Amount (in current US$) in Fiji in 2010 to that in 2013?
Offer a terse response. 1.64. What is the ratio of the Amount (in current US$) in Sri Lanka in 2010 to that in 2013?
Provide a succinct answer. 1.05. What is the ratio of the Amount (in current US$) in Middle East & North Africa (developing only) in 2011 to that in 2012?
Provide a short and direct response. 1.07. What is the ratio of the Amount (in current US$) in Fiji in 2011 to that in 2012?
Your answer should be very brief. 1.4. What is the ratio of the Amount (in current US$) of Sri Lanka in 2011 to that in 2012?
Provide a short and direct response. 0.77. What is the ratio of the Amount (in current US$) in Middle East & North Africa (developing only) in 2011 to that in 2013?
Offer a very short reply. 2.34. What is the ratio of the Amount (in current US$) in Fiji in 2011 to that in 2013?
Provide a short and direct response. 2.22. What is the ratio of the Amount (in current US$) of Sri Lanka in 2011 to that in 2013?
Your response must be concise. 0.87. What is the ratio of the Amount (in current US$) in Middle East & North Africa (developing only) in 2012 to that in 2013?
Make the answer very short. 2.19. What is the ratio of the Amount (in current US$) in Fiji in 2012 to that in 2013?
Keep it short and to the point. 1.59. What is the ratio of the Amount (in current US$) in Sri Lanka in 2012 to that in 2013?
Offer a terse response. 1.13. What is the difference between the highest and the second highest Amount (in current US$) in Middle East & North Africa (developing only)?
Keep it short and to the point. 5.62e+07. What is the difference between the highest and the second highest Amount (in current US$) in Fiji?
Keep it short and to the point. 3.95e+06. What is the difference between the highest and the second highest Amount (in current US$) of Indonesia?
Your answer should be very brief. 1.88e+08. What is the difference between the highest and the second highest Amount (in current US$) of Sri Lanka?
Your answer should be very brief. 1.38e+07. What is the difference between the highest and the lowest Amount (in current US$) in Middle East & North Africa (developing only)?
Keep it short and to the point. 9.01e+08. What is the difference between the highest and the lowest Amount (in current US$) of Fiji?
Offer a very short reply. 1.42e+07. What is the difference between the highest and the lowest Amount (in current US$) of Indonesia?
Keep it short and to the point. 4.72e+08. What is the difference between the highest and the lowest Amount (in current US$) in Sri Lanka?
Offer a very short reply. 1.98e+08. 